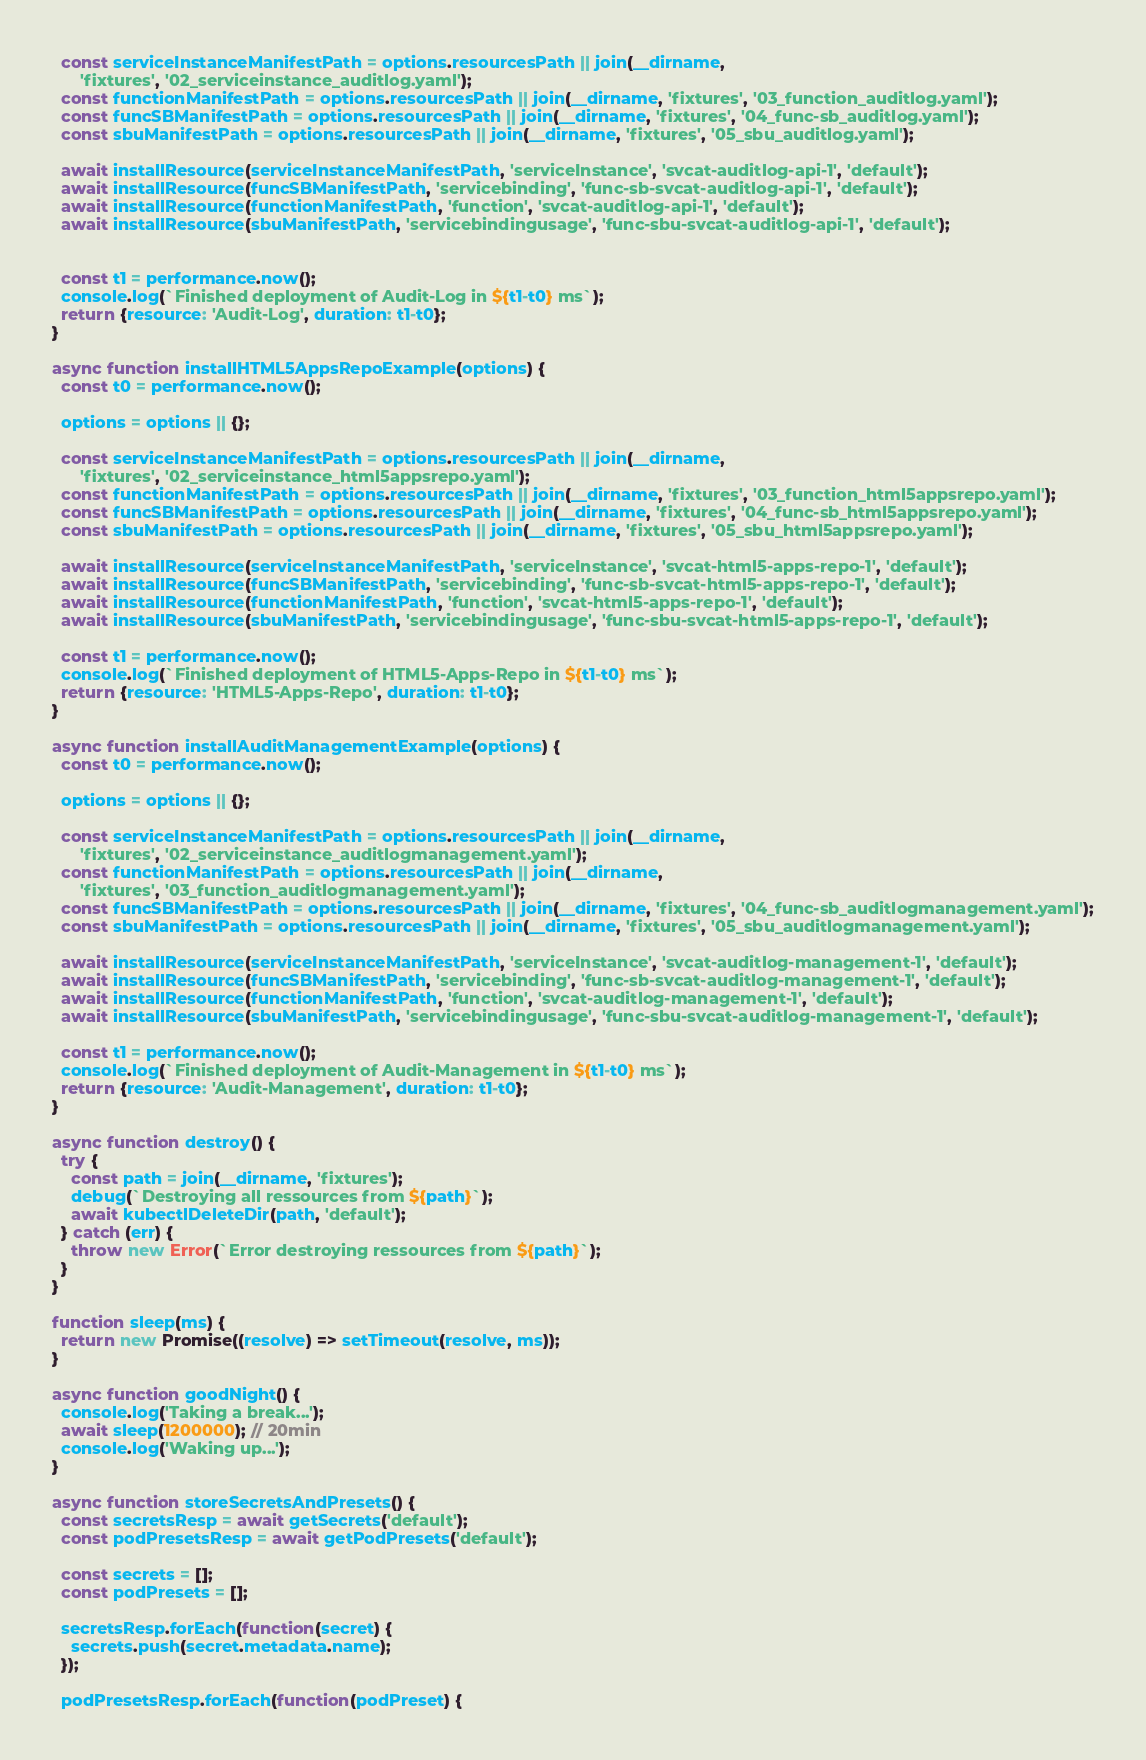<code> <loc_0><loc_0><loc_500><loc_500><_JavaScript_>
  const serviceInstanceManifestPath = options.resourcesPath || join(__dirname,
      'fixtures', '02_serviceinstance_auditlog.yaml');
  const functionManifestPath = options.resourcesPath || join(__dirname, 'fixtures', '03_function_auditlog.yaml');
  const funcSBManifestPath = options.resourcesPath || join(__dirname, 'fixtures', '04_func-sb_auditlog.yaml');
  const sbuManifestPath = options.resourcesPath || join(__dirname, 'fixtures', '05_sbu_auditlog.yaml');

  await installResource(serviceInstanceManifestPath, 'serviceInstance', 'svcat-auditlog-api-1', 'default');
  await installResource(funcSBManifestPath, 'servicebinding', 'func-sb-svcat-auditlog-api-1', 'default');
  await installResource(functionManifestPath, 'function', 'svcat-auditlog-api-1', 'default');
  await installResource(sbuManifestPath, 'servicebindingusage', 'func-sbu-svcat-auditlog-api-1', 'default');


  const t1 = performance.now();
  console.log(`Finished deployment of Audit-Log in ${t1-t0} ms`);
  return {resource: 'Audit-Log', duration: t1-t0};
}

async function installHTML5AppsRepoExample(options) {
  const t0 = performance.now();

  options = options || {};

  const serviceInstanceManifestPath = options.resourcesPath || join(__dirname,
      'fixtures', '02_serviceinstance_html5appsrepo.yaml');
  const functionManifestPath = options.resourcesPath || join(__dirname, 'fixtures', '03_function_html5appsrepo.yaml');
  const funcSBManifestPath = options.resourcesPath || join(__dirname, 'fixtures', '04_func-sb_html5appsrepo.yaml');
  const sbuManifestPath = options.resourcesPath || join(__dirname, 'fixtures', '05_sbu_html5appsrepo.yaml');

  await installResource(serviceInstanceManifestPath, 'serviceInstance', 'svcat-html5-apps-repo-1', 'default');
  await installResource(funcSBManifestPath, 'servicebinding', 'func-sb-svcat-html5-apps-repo-1', 'default');
  await installResource(functionManifestPath, 'function', 'svcat-html5-apps-repo-1', 'default');
  await installResource(sbuManifestPath, 'servicebindingusage', 'func-sbu-svcat-html5-apps-repo-1', 'default');

  const t1 = performance.now();
  console.log(`Finished deployment of HTML5-Apps-Repo in ${t1-t0} ms`);
  return {resource: 'HTML5-Apps-Repo', duration: t1-t0};
}

async function installAuditManagementExample(options) {
  const t0 = performance.now();

  options = options || {};

  const serviceInstanceManifestPath = options.resourcesPath || join(__dirname,
      'fixtures', '02_serviceinstance_auditlogmanagement.yaml');
  const functionManifestPath = options.resourcesPath || join(__dirname,
      'fixtures', '03_function_auditlogmanagement.yaml');
  const funcSBManifestPath = options.resourcesPath || join(__dirname, 'fixtures', '04_func-sb_auditlogmanagement.yaml');
  const sbuManifestPath = options.resourcesPath || join(__dirname, 'fixtures', '05_sbu_auditlogmanagement.yaml');

  await installResource(serviceInstanceManifestPath, 'serviceInstance', 'svcat-auditlog-management-1', 'default');
  await installResource(funcSBManifestPath, 'servicebinding', 'func-sb-svcat-auditlog-management-1', 'default');
  await installResource(functionManifestPath, 'function', 'svcat-auditlog-management-1', 'default');
  await installResource(sbuManifestPath, 'servicebindingusage', 'func-sbu-svcat-auditlog-management-1', 'default');

  const t1 = performance.now();
  console.log(`Finished deployment of Audit-Management in ${t1-t0} ms`);
  return {resource: 'Audit-Management', duration: t1-t0};
}

async function destroy() {
  try {
    const path = join(__dirname, 'fixtures');
    debug(`Destroying all ressources from ${path}`);
    await kubectlDeleteDir(path, 'default');
  } catch (err) {
    throw new Error(`Error destroying ressources from ${path}`);
  }
}

function sleep(ms) {
  return new Promise((resolve) => setTimeout(resolve, ms));
}

async function goodNight() {
  console.log('Taking a break...');
  await sleep(1200000); // 20min
  console.log('Waking up...');
}

async function storeSecretsAndPresets() {
  const secretsResp = await getSecrets('default');
  const podPresetsResp = await getPodPresets('default');

  const secrets = [];
  const podPresets = [];

  secretsResp.forEach(function(secret) {
    secrets.push(secret.metadata.name);
  });

  podPresetsResp.forEach(function(podPreset) {</code> 